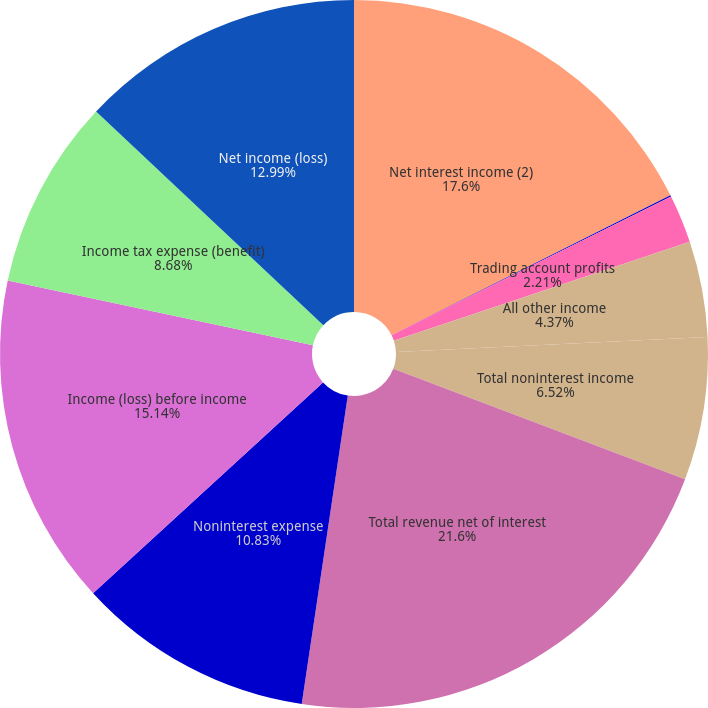Convert chart to OTSL. <chart><loc_0><loc_0><loc_500><loc_500><pie_chart><fcel>Net interest income (2)<fcel>Investment and brokerage<fcel>Trading account profits<fcel>All other income<fcel>Total noninterest income<fcel>Total revenue net of interest<fcel>Noninterest expense<fcel>Income (loss) before income<fcel>Income tax expense (benefit)<fcel>Net income (loss)<nl><fcel>17.6%<fcel>0.06%<fcel>2.21%<fcel>4.37%<fcel>6.52%<fcel>21.6%<fcel>10.83%<fcel>15.14%<fcel>8.68%<fcel>12.99%<nl></chart> 